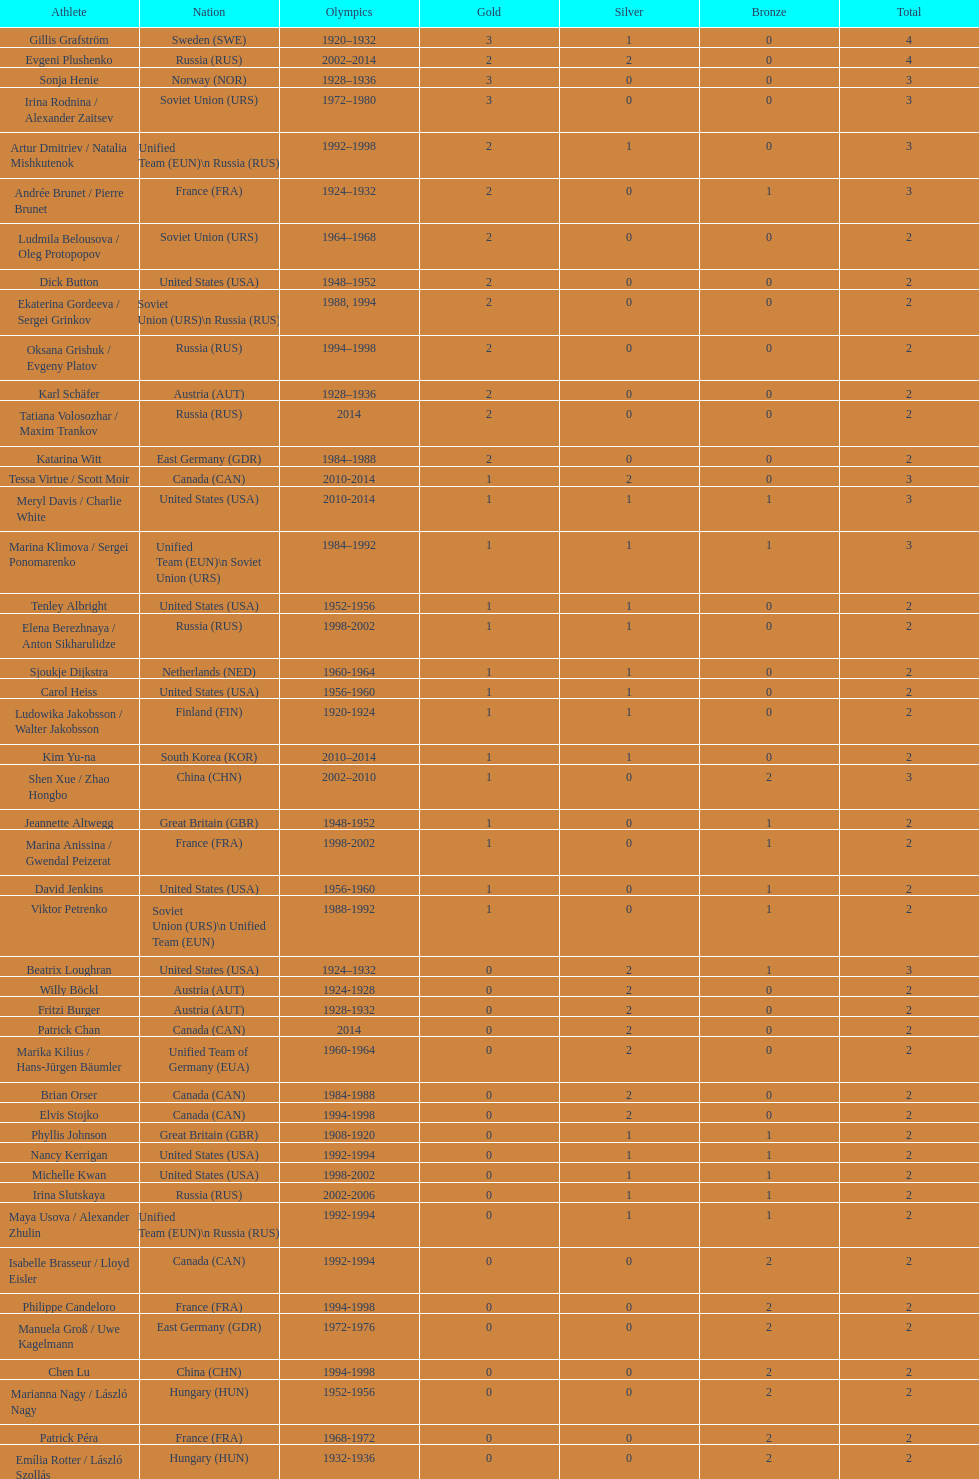Who is the athlete that came from south korea following the year 2010? Kim Yu-na. 